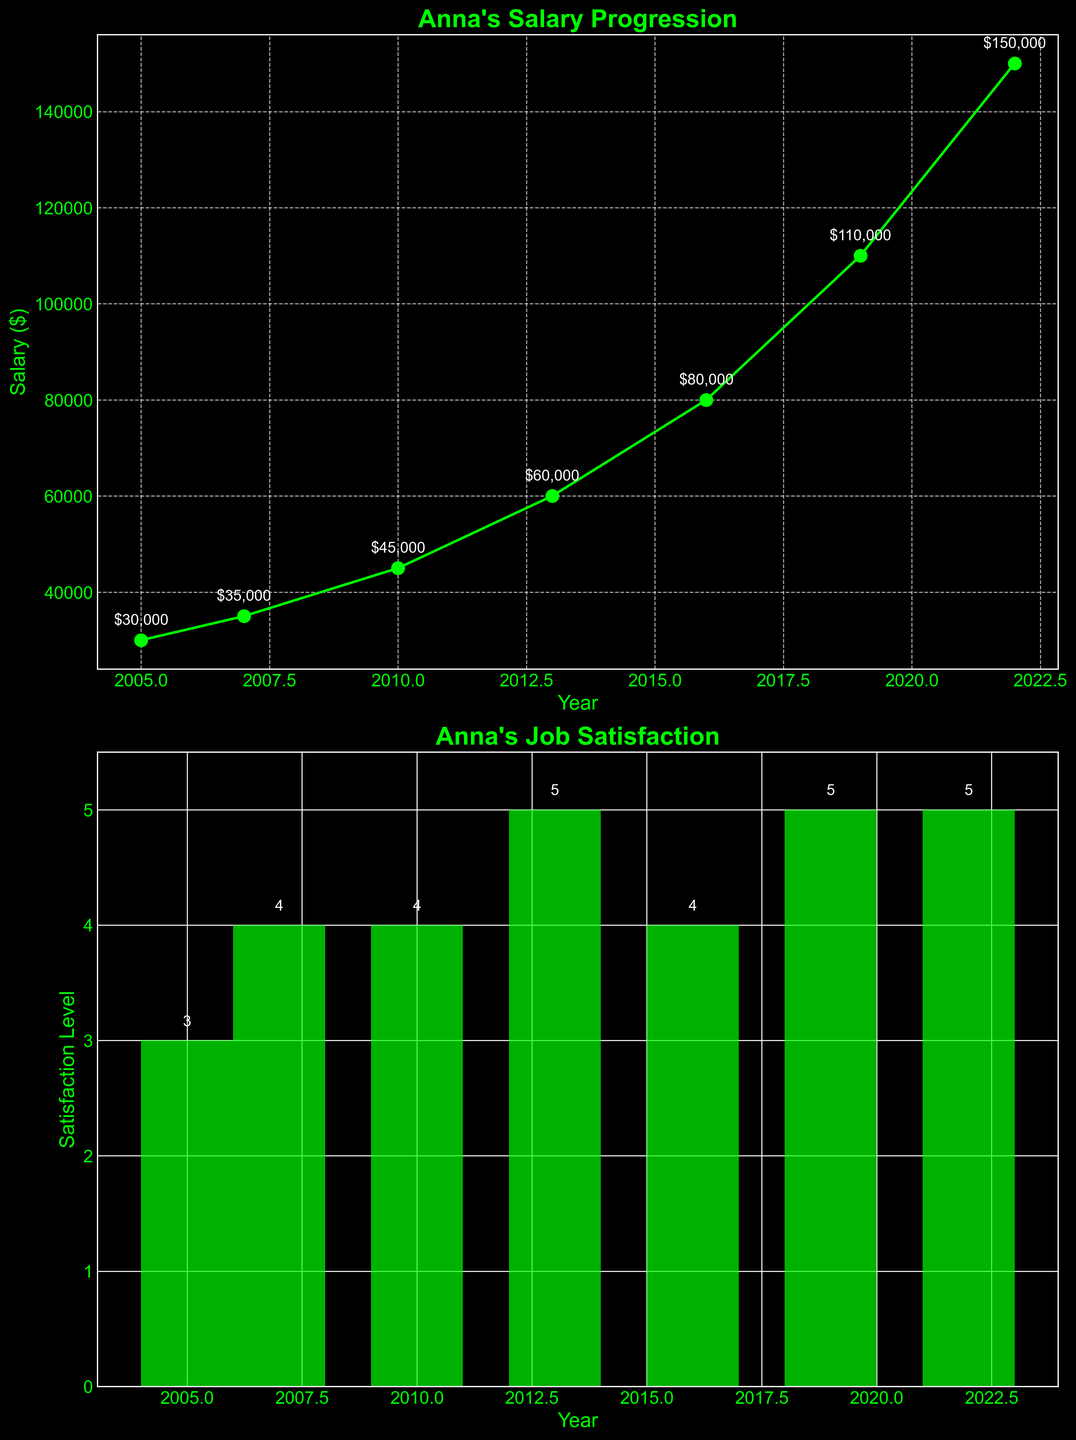What is the highest job satisfaction level Anna achieved? The highest job satisfaction level can be found in the bar plot titled "Anna's Job Satisfaction". The tallest bar represents the highest job satisfaction level, which is 5.
Answer: 5 In which year did Anna's salary first exceed $100,000? To find the year when Anna's salary first exceeds $100,000, observe the salary progression plot. The data point at 2019 shows a salary of $110,000, which is the first year it exceeds $100,000.
Answer: 2019 What is the difference between Anna's salary in 2010 and 2016? Look at the salary progression plot and identify the salaries in 2010 and 2016. In 2010, the salary is $45,000, and in 2016 it is $80,000. The difference is $80,000 - $45,000 = $35,000.
Answer: $35,000 Compare Anna's job satisfaction levels in 2007 and 2019. Which one is higher? By looking at the bar plot, we see that the job satisfaction in 2007 is 4 and in 2019 is 5. Therefore, the job satisfaction is higher in 2019.
Answer: 2019 How many years did Anna remain at a job with a satisfaction level of 4? To determine this, add the years where the bar plot shows a satisfaction level of 4. These years are 2007 and 2016, so Anna remained in jobs with a satisfaction level of 4 for 2 years.
Answer: 2 When did Anna hold the title "Senior Graphic Designer"? The data for job titles is not directly plotted but can be inferred from the associated years. Anna held the "Senior Graphic Designer" title in 2010, as indicated in the data.
Answer: 2010 What is the average salary increase per job title change between 2005 and 2022? First, calculate the total salary increase over the years: $150,000 (2022) - $30,000 (2005) = $120,000. Anna had 7 different job titles (assumed from changes in years), so the average increase is $120,000 / 6 = $20,000 per job title change.
Answer: $20,000 Which company was Anna working for when she first became Art Director? Refer to the data provided and the year when she became Art Director (2013). The company listed for 2013 is "Innovative Visuals".
Answer: Innovative Visuals 